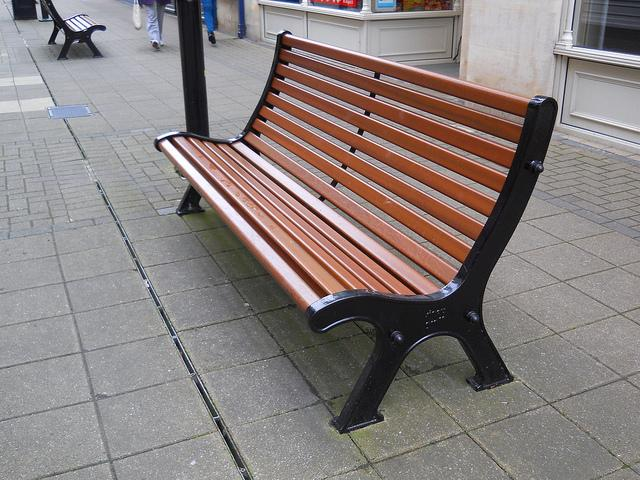This bench is located where? sidewalk 